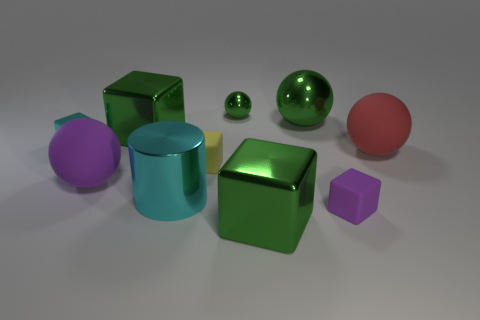There is a large object that is the same color as the small shiny cube; what is its shape?
Ensure brevity in your answer.  Cylinder. How many things are purple rubber balls or big cyan rubber blocks?
Provide a short and direct response. 1. Does the metallic cube right of the cyan shiny cylinder have the same size as the purple matte cube in front of the tiny cyan object?
Give a very brief answer. No. How many other objects are there of the same size as the purple sphere?
Your response must be concise. 5. What number of things are things on the right side of the big purple ball or shiny blocks behind the large cyan cylinder?
Keep it short and to the point. 9. Are the cylinder and the big green sphere behind the large metallic cylinder made of the same material?
Make the answer very short. Yes. How many other things are the same shape as the small purple object?
Give a very brief answer. 4. What is the big green cube in front of the rubber thing right of the tiny thing in front of the purple matte ball made of?
Make the answer very short. Metal. Is the number of large blocks that are in front of the small yellow block the same as the number of brown matte cylinders?
Keep it short and to the point. No. Does the object that is on the left side of the big purple rubber sphere have the same material as the sphere to the left of the yellow rubber object?
Offer a terse response. No. 